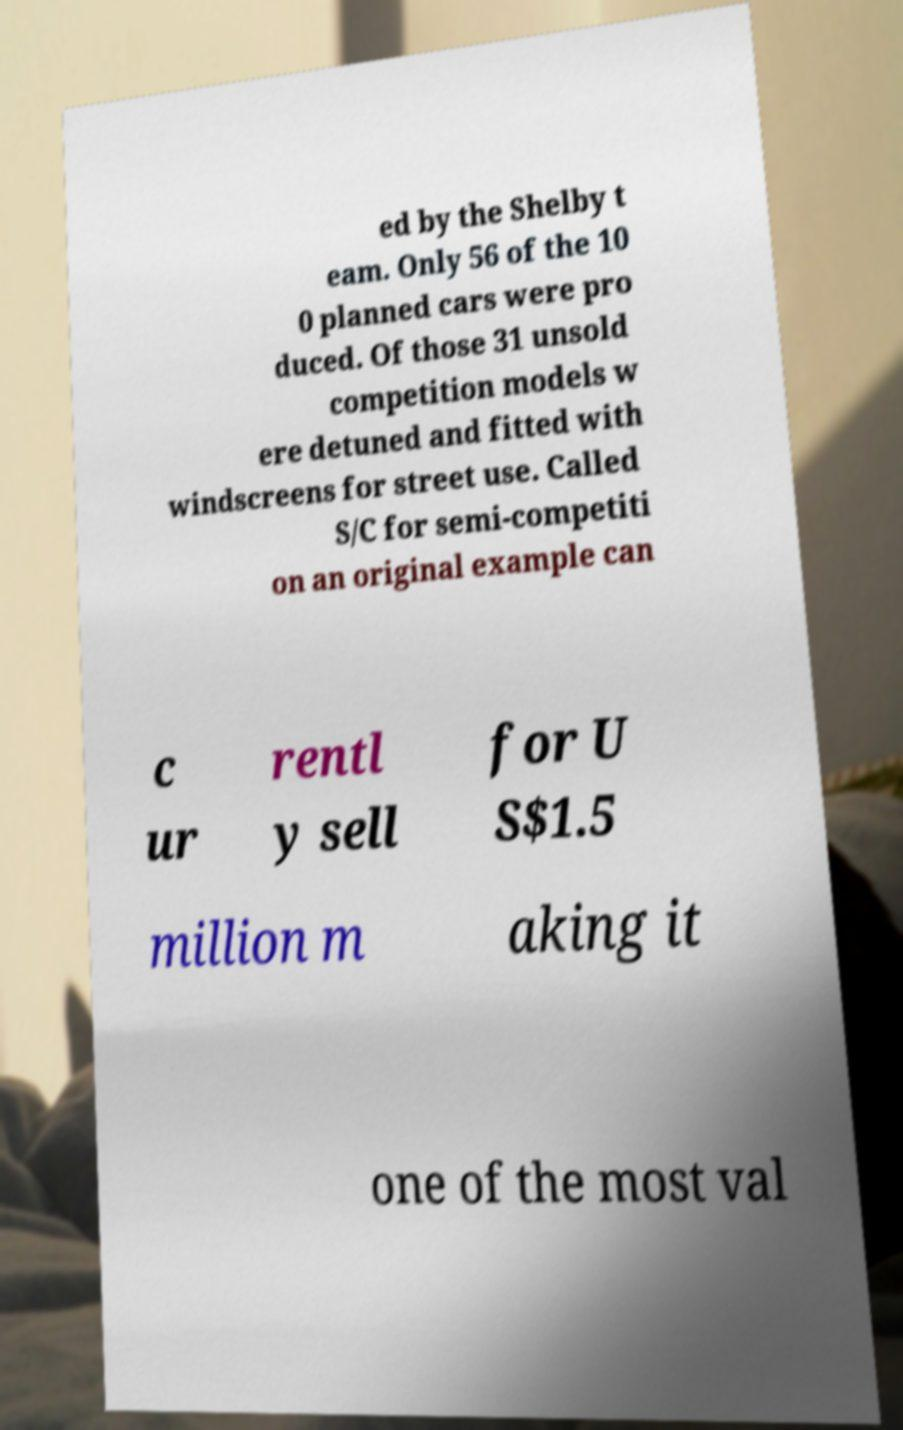Can you read and provide the text displayed in the image?This photo seems to have some interesting text. Can you extract and type it out for me? ed by the Shelby t eam. Only 56 of the 10 0 planned cars were pro duced. Of those 31 unsold competition models w ere detuned and fitted with windscreens for street use. Called S/C for semi-competiti on an original example can c ur rentl y sell for U S$1.5 million m aking it one of the most val 